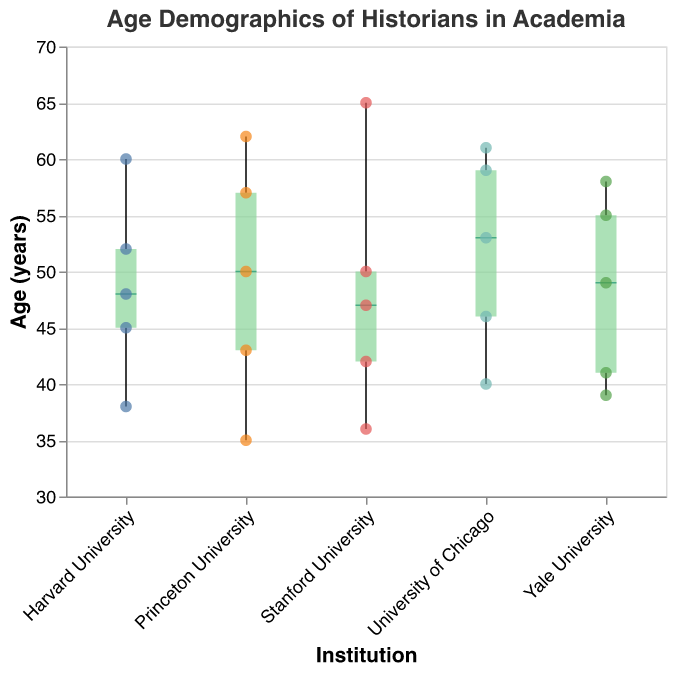What is the median age of historians at Princeton University? To find the median age at Princeton University, locate the middle value from the sorted list of ages. The ages are 35, 43, 50, 57, and 62. The median value is the one in the middle, which is 50.
Answer: 50 Which institution has the oldest historian? Identify the maximum age value across all institutions. The highest age is 65, found at Stanford University.
Answer: Stanford University What is the range of ages for historians at Yale University? To find the range of ages at Yale University, subtract the youngest age from the oldest age. The ages are 39, 41, 49, 55, and 58. The range is 58 - 39 = 19.
Answer: 19 What is the interquartile range (IQR) for ages at Harvard University? The interquartile range (IQR) is the difference between the third quartile (Q3) and the first quartile (Q1). The ages are 38, 45, 48, 52, and 60. Q1 is the median of the lower half (38, 45, 48), which is 45, and Q3 is the median of the upper half (48, 52, 60), which is 52. IQR = 52 - 45 = 7.
Answer: 7 Which institution has the widest spread of ages? Identify the institution with the largest range of ages by comparing the range (max - min) for each institution. Stanford's ages range from 36 to 65, a spread of 29, which is the widest.
Answer: Stanford University How many historians at the University of Chicago are aged 50 or older? Count the number of data points with ages 50 or older at the University of Chicago. The ages are 40, 46, 53, 59, and 61. There are three ages 50 or older: 53, 59, 61.
Answer: 3 What is the median age of historians across all institutions? Combine all the ages from every institution and find the median. The sorted list of ages is 35, 36, 38, 39, 40, 41, 42, 43, 45, 46, 47, 48, 49, 50, 50, 52, 53, 55, 57, 58, 59, 60, 61, 62, 65. With 25 data points, the median is the 13th age in the sorted list, which is 49.
Answer: 49 Which institution has the most consistent age demographics, indicated by the smallest range of ages? Identify the institution with the smallest range in ages by finding the difference between the maximum and minimum ages for each institution. Yale's ages range from 39 to 58, a range of 19, which is the smallest.
Answer: Yale University 